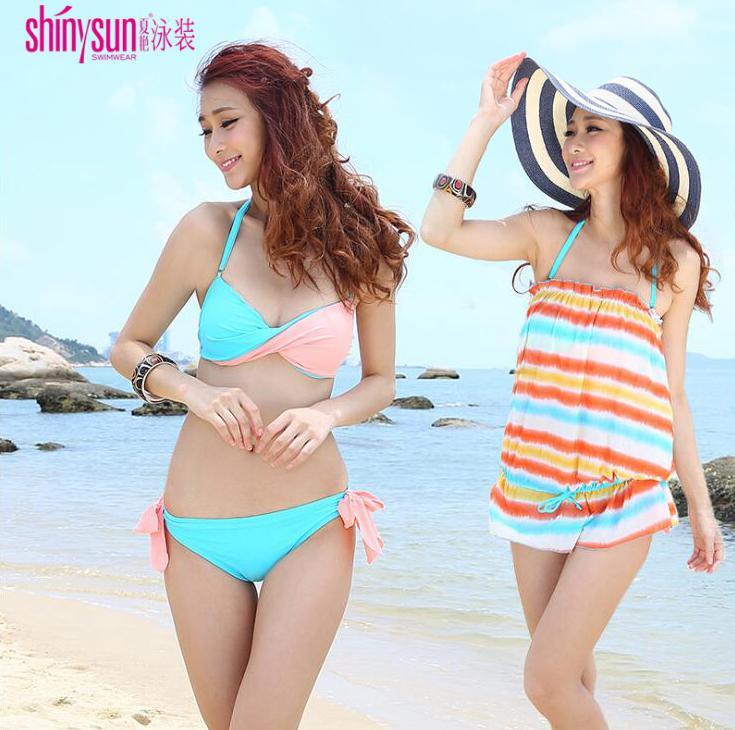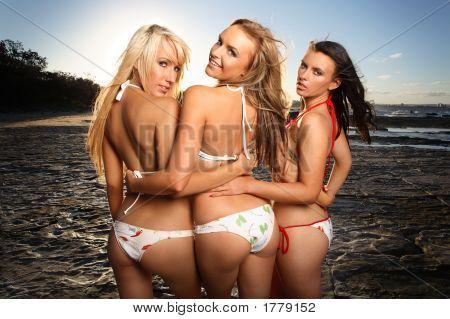The first image is the image on the left, the second image is the image on the right. Examine the images to the left and right. Is the description "In one image, the backsides of three women dressed in bikinis are visible" accurate? Answer yes or no. Yes. 